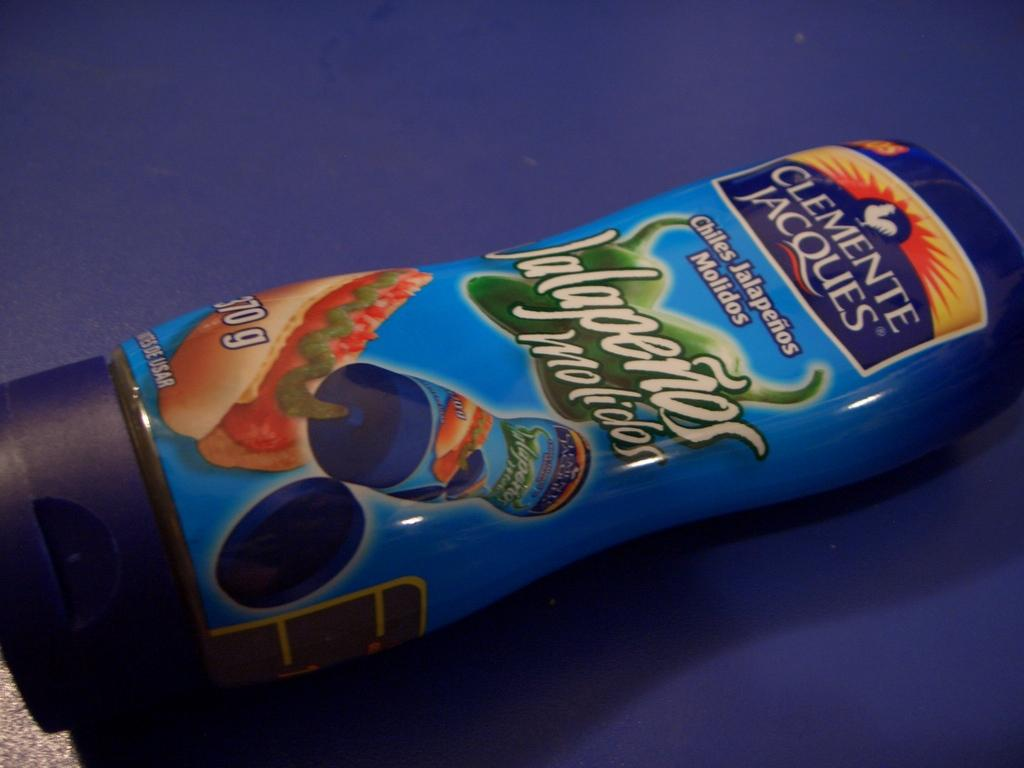<image>
Relay a brief, clear account of the picture shown. A label for a Clemente Jacques product has jalapenos on it. 